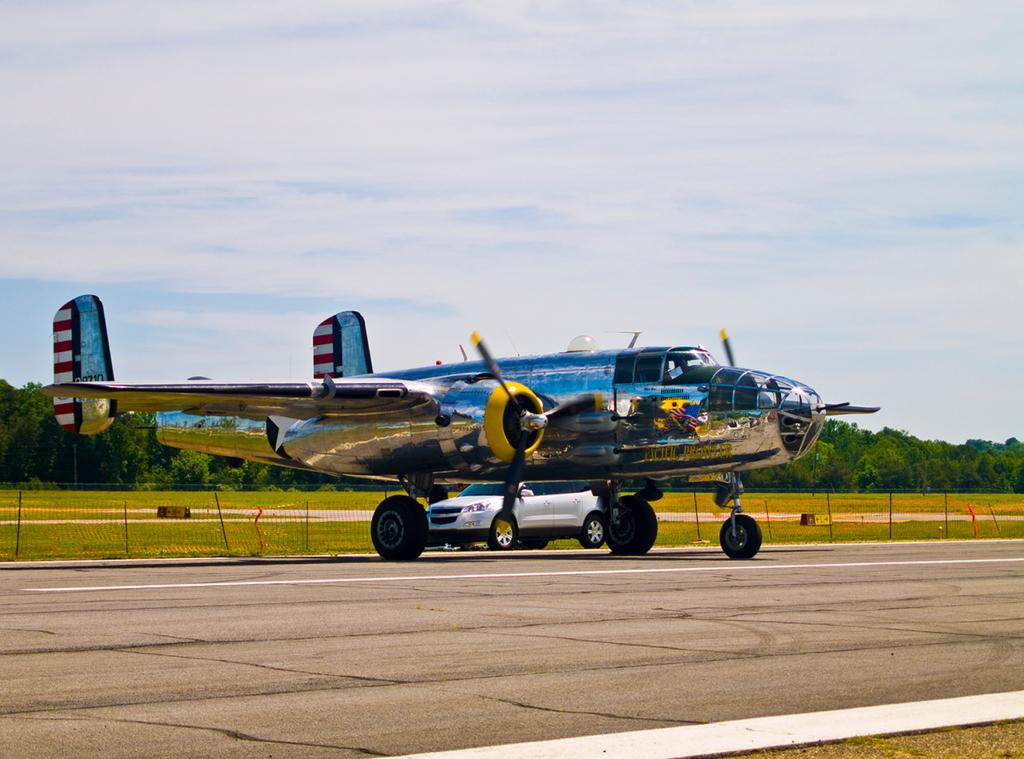What is the main subject of the image? The main subject of the image is an aircraft. What else can be seen on the runway in the image? There is a car on the runway in the image. What type of natural scenery is visible in the image? Trees are visible in the image. What is visible in the background of the image? The sky is visible in the image. What type of barrier is present in the image? There is fencing in the image. What type of bone can be seen in the image? There is no bone present in the image. What type of ship can be seen in the image? There is no ship present in the image. 